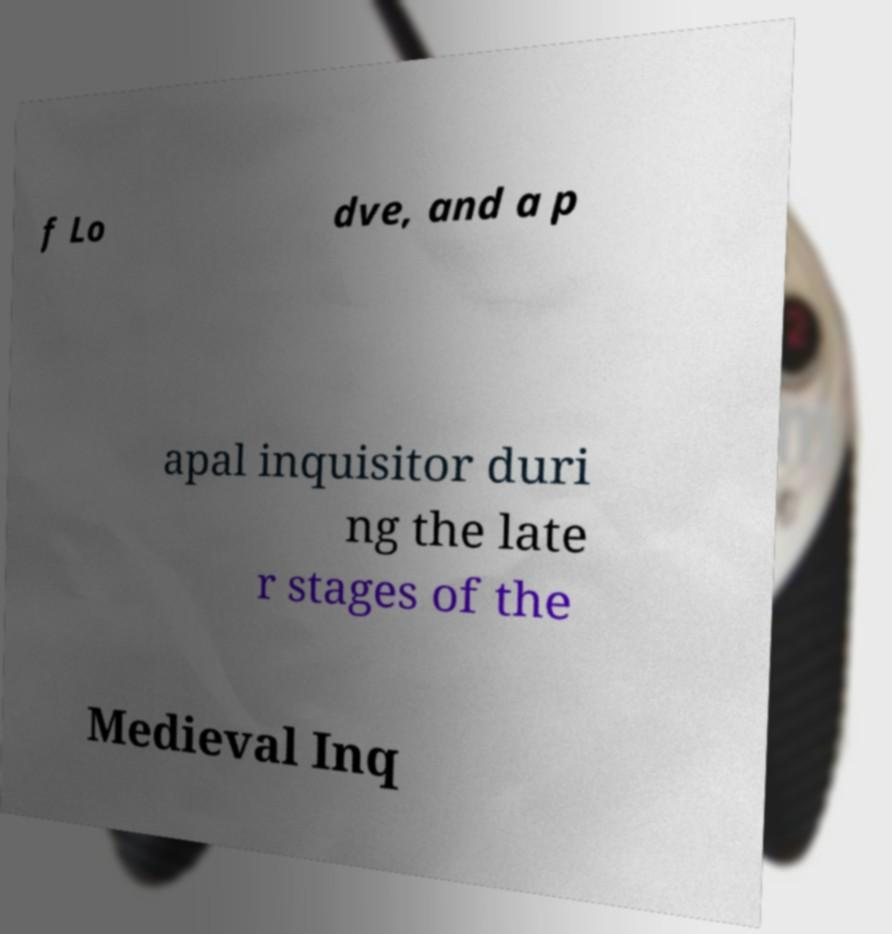What messages or text are displayed in this image? I need them in a readable, typed format. f Lo dve, and a p apal inquisitor duri ng the late r stages of the Medieval Inq 